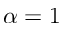<formula> <loc_0><loc_0><loc_500><loc_500>\alpha = 1</formula> 